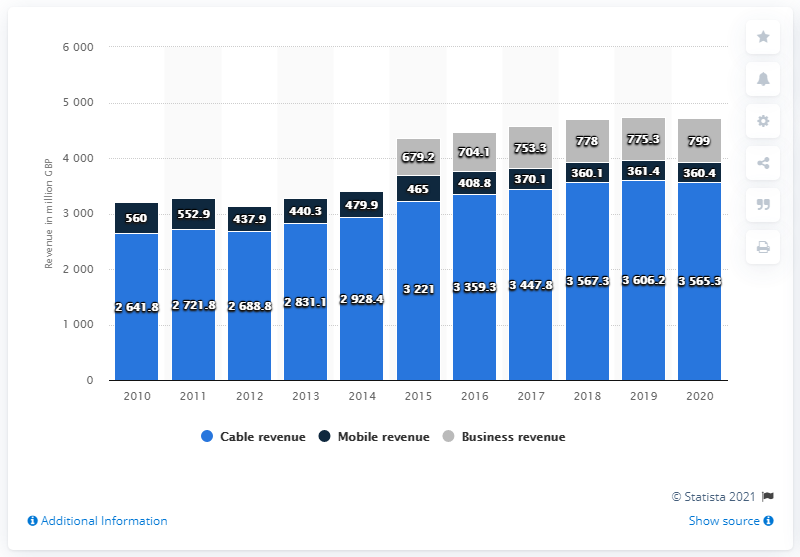Highlight a few significant elements in this photo. In 2020, Virgin Media Inc.'s cable revenue was approximately 3565.3 million dollars. Virgin Media's mobile revenue has remained stable for the last three years, with a total of 360.4 British pounds. 